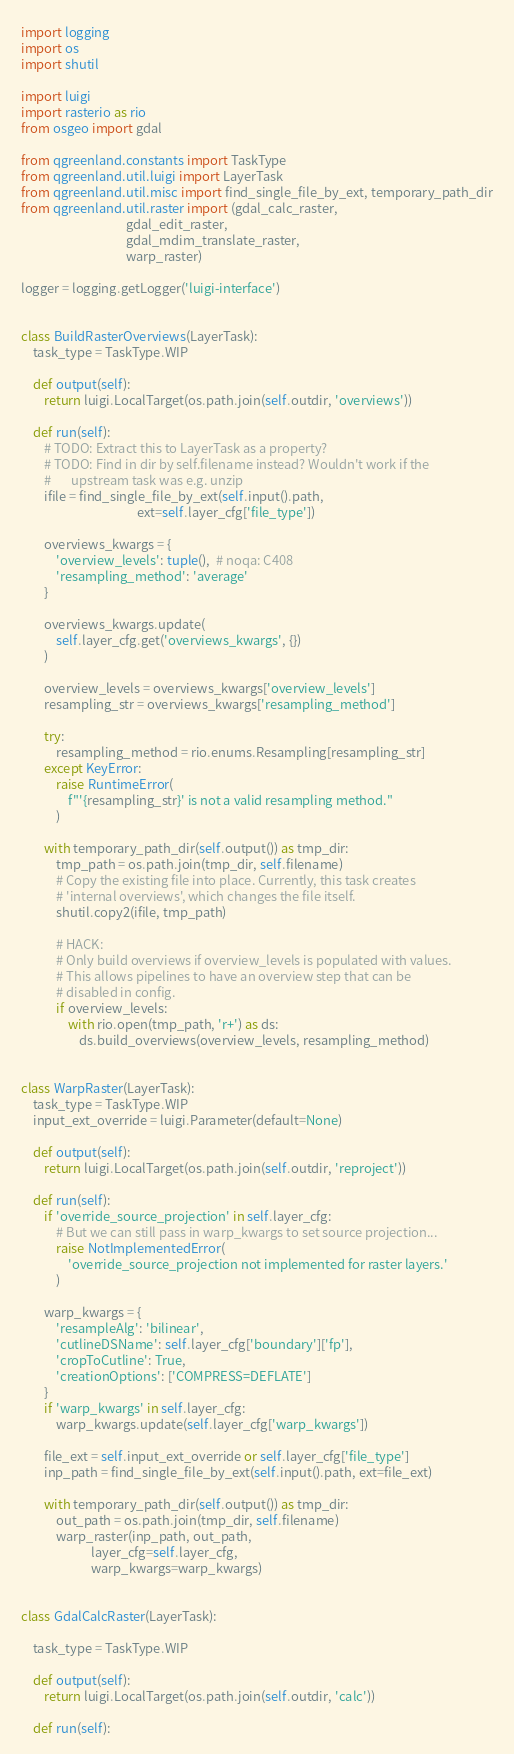Convert code to text. <code><loc_0><loc_0><loc_500><loc_500><_Python_>import logging
import os
import shutil

import luigi
import rasterio as rio
from osgeo import gdal

from qgreenland.constants import TaskType
from qgreenland.util.luigi import LayerTask
from qgreenland.util.misc import find_single_file_by_ext, temporary_path_dir
from qgreenland.util.raster import (gdal_calc_raster,
                                    gdal_edit_raster,
                                    gdal_mdim_translate_raster,
                                    warp_raster)

logger = logging.getLogger('luigi-interface')


class BuildRasterOverviews(LayerTask):
    task_type = TaskType.WIP

    def output(self):
        return luigi.LocalTarget(os.path.join(self.outdir, 'overviews'))

    def run(self):
        # TODO: Extract this to LayerTask as a property?
        # TODO: Find in dir by self.filename instead? Wouldn't work if the
        #       upstream task was e.g. unzip
        ifile = find_single_file_by_ext(self.input().path,
                                        ext=self.layer_cfg['file_type'])

        overviews_kwargs = {
            'overview_levels': tuple(),  # noqa: C408
            'resampling_method': 'average'
        }

        overviews_kwargs.update(
            self.layer_cfg.get('overviews_kwargs', {})
        )

        overview_levels = overviews_kwargs['overview_levels']
        resampling_str = overviews_kwargs['resampling_method']

        try:
            resampling_method = rio.enums.Resampling[resampling_str]
        except KeyError:
            raise RuntimeError(
                f"'{resampling_str}' is not a valid resampling method."
            )

        with temporary_path_dir(self.output()) as tmp_dir:
            tmp_path = os.path.join(tmp_dir, self.filename)
            # Copy the existing file into place. Currently, this task creates
            # 'internal overviews', which changes the file itself.
            shutil.copy2(ifile, tmp_path)

            # HACK:
            # Only build overviews if overview_levels is populated with values.
            # This allows pipelines to have an overview step that can be
            # disabled in config.
            if overview_levels:
                with rio.open(tmp_path, 'r+') as ds:
                    ds.build_overviews(overview_levels, resampling_method)


class WarpRaster(LayerTask):
    task_type = TaskType.WIP
    input_ext_override = luigi.Parameter(default=None)

    def output(self):
        return luigi.LocalTarget(os.path.join(self.outdir, 'reproject'))

    def run(self):
        if 'override_source_projection' in self.layer_cfg:
            # But we can still pass in warp_kwargs to set source projection...
            raise NotImplementedError(
                'override_source_projection not implemented for raster layers.'
            )

        warp_kwargs = {
            'resampleAlg': 'bilinear',
            'cutlineDSName': self.layer_cfg['boundary']['fp'],
            'cropToCutline': True,
            'creationOptions': ['COMPRESS=DEFLATE']
        }
        if 'warp_kwargs' in self.layer_cfg:
            warp_kwargs.update(self.layer_cfg['warp_kwargs'])

        file_ext = self.input_ext_override or self.layer_cfg['file_type']
        inp_path = find_single_file_by_ext(self.input().path, ext=file_ext)

        with temporary_path_dir(self.output()) as tmp_dir:
            out_path = os.path.join(tmp_dir, self.filename)
            warp_raster(inp_path, out_path,
                        layer_cfg=self.layer_cfg,
                        warp_kwargs=warp_kwargs)


class GdalCalcRaster(LayerTask):

    task_type = TaskType.WIP

    def output(self):
        return luigi.LocalTarget(os.path.join(self.outdir, 'calc'))

    def run(self):</code> 